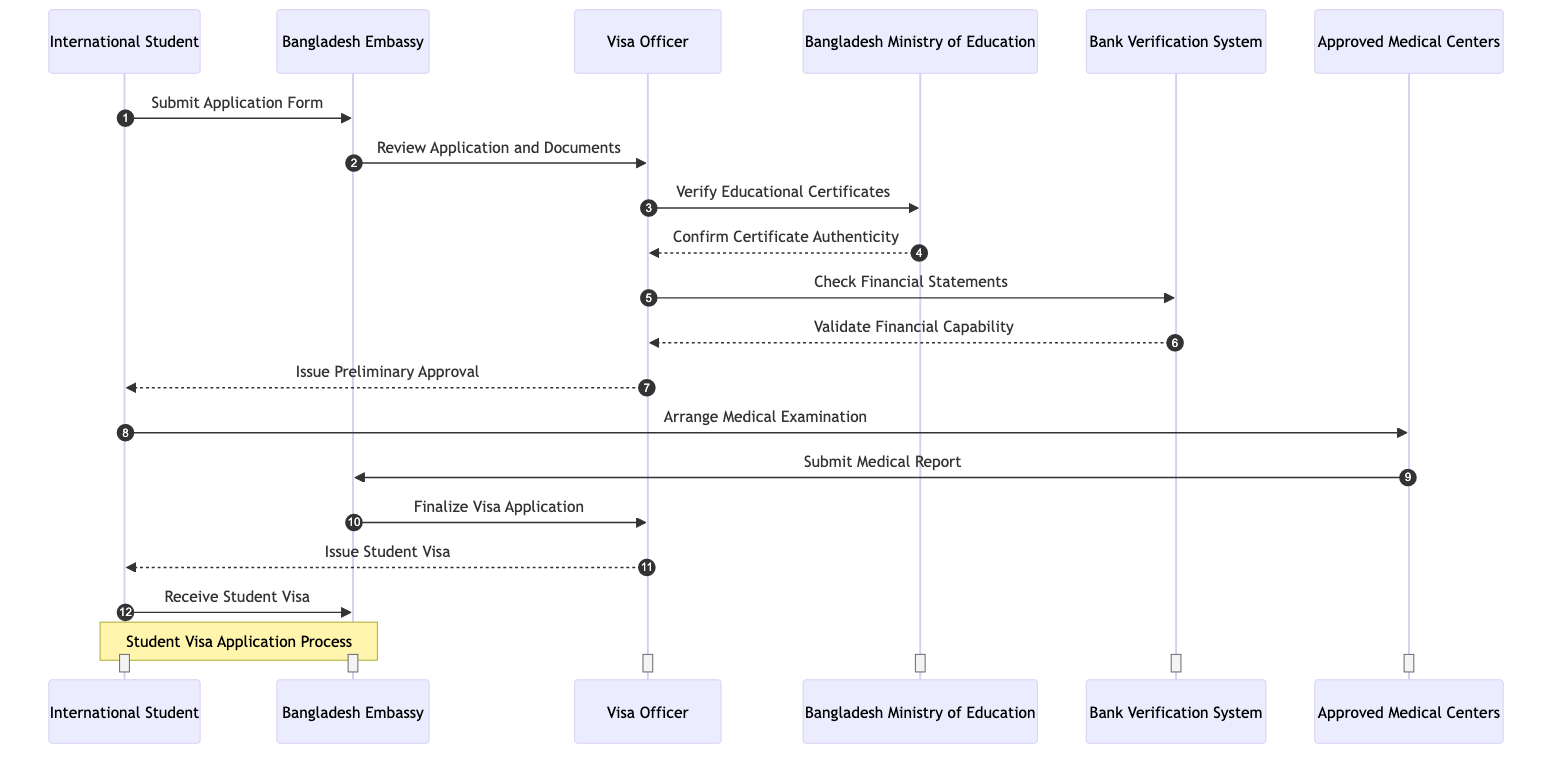What is the first action in the sequence? The first action in the sequence is the International Student submitting the Application Form to the Bangladesh Embassy. This is clearly indicated as the first line in the diagram.
Answer: Submit Application Form How many participants are involved in the process? The diagram includes six distinct participants: International Student, Bangladesh Embassy, Visa Officer, Bangladesh Ministry of Education, Bank Verification System, and Approved Medical Centers. Counting each participant shows that there are six.
Answer: Six Who verifies the educational certificates? The Visa Officer is responsible for verifying the educational certificates. This is shown in the interaction where the Visa Officer sends a verification request to the Bangladesh Ministry of Education.
Answer: Visa Officer What comes after the Visa Officer issues the preliminary approval? After the Visa Officer issues the preliminary approval, the International Student is expected to arrange a medical examination at the Approved Medical Centers. The sequence clearly shows this action following the approval.
Answer: Arrange Medical Examination Which entity confirms the authenticity of the educational certificates? The Bangladesh Ministry of Education confirms the authenticity of the educational certificates. This is indicated in the diagram where the Visa Officer receives confirmation from this entity.
Answer: Bangladesh Ministry of Education What happens after the student receives the student visa? After the International Student receives the student visa, the process concludes, as that is the last action depicted in the diagram. There are no further actions following this step.
Answer: Receive Student Visa How is the financial capability validated? The financial capability is validated through a check conducted by the Bank Verification System, which is responsible for ensuring that the Visa Officer's requirements are satisfied before issuing any approval.
Answer: Validate Financial Capability What is the last action performed by the Bangladesh Embassy? The last action performed by the Bangladesh Embassy is finalizing the visa application, which is shown right before the Visa Officer issues the student visa. This indicates the Embassy's crucial role in the concluding phase of the process.
Answer: Finalize Visa Application 